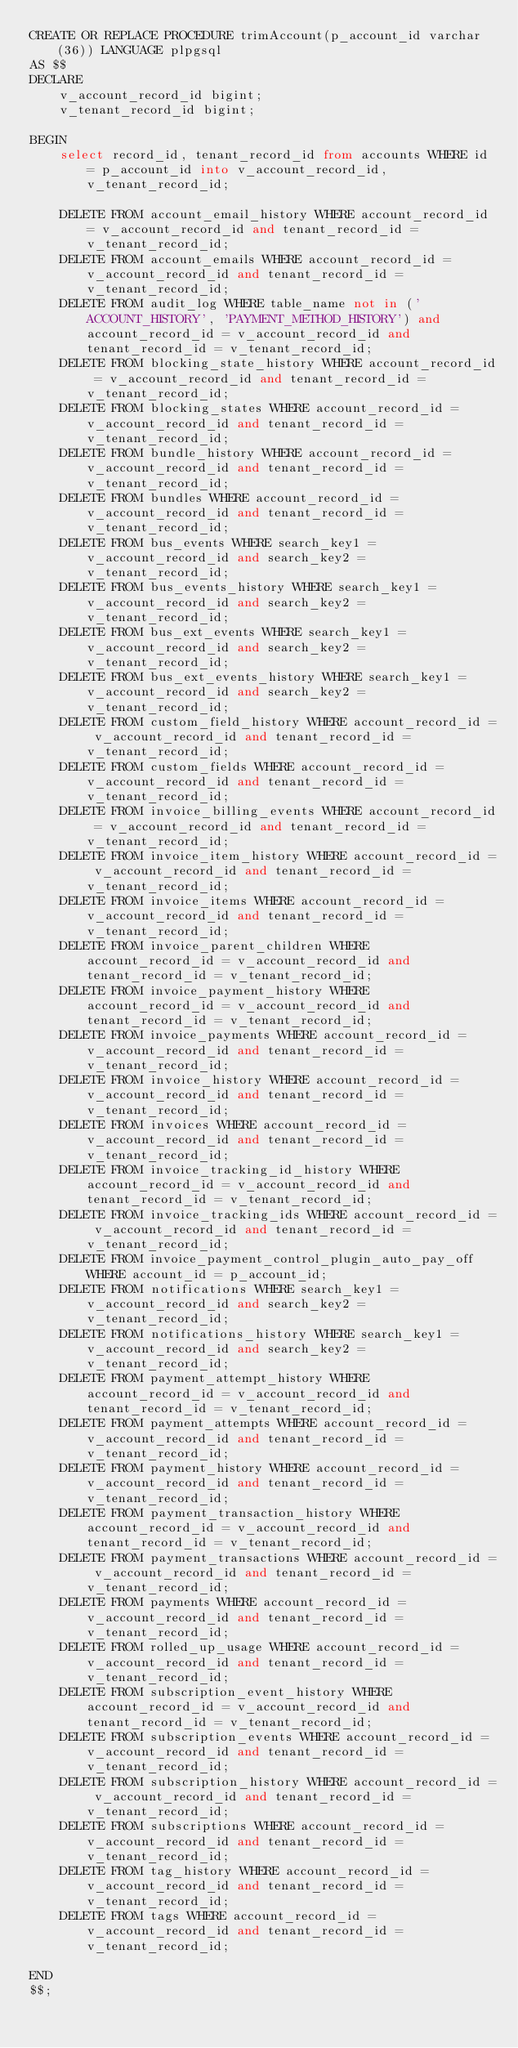<code> <loc_0><loc_0><loc_500><loc_500><_SQL_>CREATE OR REPLACE PROCEDURE trimAccount(p_account_id varchar(36)) LANGUAGE plpgsql
AS $$
DECLARE
    v_account_record_id bigint;
    v_tenant_record_id bigint;

BEGIN
    select record_id, tenant_record_id from accounts WHERE id = p_account_id into v_account_record_id, v_tenant_record_id;

    DELETE FROM account_email_history WHERE account_record_id = v_account_record_id and tenant_record_id = v_tenant_record_id;
    DELETE FROM account_emails WHERE account_record_id = v_account_record_id and tenant_record_id = v_tenant_record_id;
    DELETE FROM audit_log WHERE table_name not in ('ACCOUNT_HISTORY', 'PAYMENT_METHOD_HISTORY') and account_record_id = v_account_record_id and tenant_record_id = v_tenant_record_id;
    DELETE FROM blocking_state_history WHERE account_record_id = v_account_record_id and tenant_record_id = v_tenant_record_id;
    DELETE FROM blocking_states WHERE account_record_id = v_account_record_id and tenant_record_id = v_tenant_record_id;
    DELETE FROM bundle_history WHERE account_record_id = v_account_record_id and tenant_record_id = v_tenant_record_id;
    DELETE FROM bundles WHERE account_record_id = v_account_record_id and tenant_record_id = v_tenant_record_id;
    DELETE FROM bus_events WHERE search_key1 = v_account_record_id and search_key2 = v_tenant_record_id;
    DELETE FROM bus_events_history WHERE search_key1 = v_account_record_id and search_key2 = v_tenant_record_id;
    DELETE FROM bus_ext_events WHERE search_key1 = v_account_record_id and search_key2 = v_tenant_record_id;
    DELETE FROM bus_ext_events_history WHERE search_key1 = v_account_record_id and search_key2 = v_tenant_record_id;
    DELETE FROM custom_field_history WHERE account_record_id = v_account_record_id and tenant_record_id = v_tenant_record_id;
    DELETE FROM custom_fields WHERE account_record_id = v_account_record_id and tenant_record_id = v_tenant_record_id;
    DELETE FROM invoice_billing_events WHERE account_record_id = v_account_record_id and tenant_record_id = v_tenant_record_id;
    DELETE FROM invoice_item_history WHERE account_record_id = v_account_record_id and tenant_record_id = v_tenant_record_id;
    DELETE FROM invoice_items WHERE account_record_id = v_account_record_id and tenant_record_id = v_tenant_record_id;
    DELETE FROM invoice_parent_children WHERE account_record_id = v_account_record_id and tenant_record_id = v_tenant_record_id;
    DELETE FROM invoice_payment_history WHERE account_record_id = v_account_record_id and tenant_record_id = v_tenant_record_id;
    DELETE FROM invoice_payments WHERE account_record_id = v_account_record_id and tenant_record_id = v_tenant_record_id;
    DELETE FROM invoice_history WHERE account_record_id = v_account_record_id and tenant_record_id = v_tenant_record_id;
    DELETE FROM invoices WHERE account_record_id = v_account_record_id and tenant_record_id = v_tenant_record_id;
    DELETE FROM invoice_tracking_id_history WHERE account_record_id = v_account_record_id and tenant_record_id = v_tenant_record_id;
    DELETE FROM invoice_tracking_ids WHERE account_record_id = v_account_record_id and tenant_record_id = v_tenant_record_id;
    DELETE FROM invoice_payment_control_plugin_auto_pay_off WHERE account_id = p_account_id;
    DELETE FROM notifications WHERE search_key1 = v_account_record_id and search_key2 = v_tenant_record_id;
    DELETE FROM notifications_history WHERE search_key1 = v_account_record_id and search_key2 = v_tenant_record_id;
    DELETE FROM payment_attempt_history WHERE account_record_id = v_account_record_id and tenant_record_id = v_tenant_record_id;
    DELETE FROM payment_attempts WHERE account_record_id = v_account_record_id and tenant_record_id = v_tenant_record_id;
    DELETE FROM payment_history WHERE account_record_id = v_account_record_id and tenant_record_id = v_tenant_record_id;
    DELETE FROM payment_transaction_history WHERE account_record_id = v_account_record_id and tenant_record_id = v_tenant_record_id;
    DELETE FROM payment_transactions WHERE account_record_id = v_account_record_id and tenant_record_id = v_tenant_record_id;
    DELETE FROM payments WHERE account_record_id = v_account_record_id and tenant_record_id = v_tenant_record_id;
    DELETE FROM rolled_up_usage WHERE account_record_id = v_account_record_id and tenant_record_id = v_tenant_record_id;
    DELETE FROM subscription_event_history WHERE account_record_id = v_account_record_id and tenant_record_id = v_tenant_record_id;
    DELETE FROM subscription_events WHERE account_record_id = v_account_record_id and tenant_record_id = v_tenant_record_id;
    DELETE FROM subscription_history WHERE account_record_id = v_account_record_id and tenant_record_id = v_tenant_record_id;
    DELETE FROM subscriptions WHERE account_record_id = v_account_record_id and tenant_record_id = v_tenant_record_id;
    DELETE FROM tag_history WHERE account_record_id = v_account_record_id and tenant_record_id = v_tenant_record_id;
    DELETE FROM tags WHERE account_record_id = v_account_record_id and tenant_record_id = v_tenant_record_id;

END
$$;
</code> 